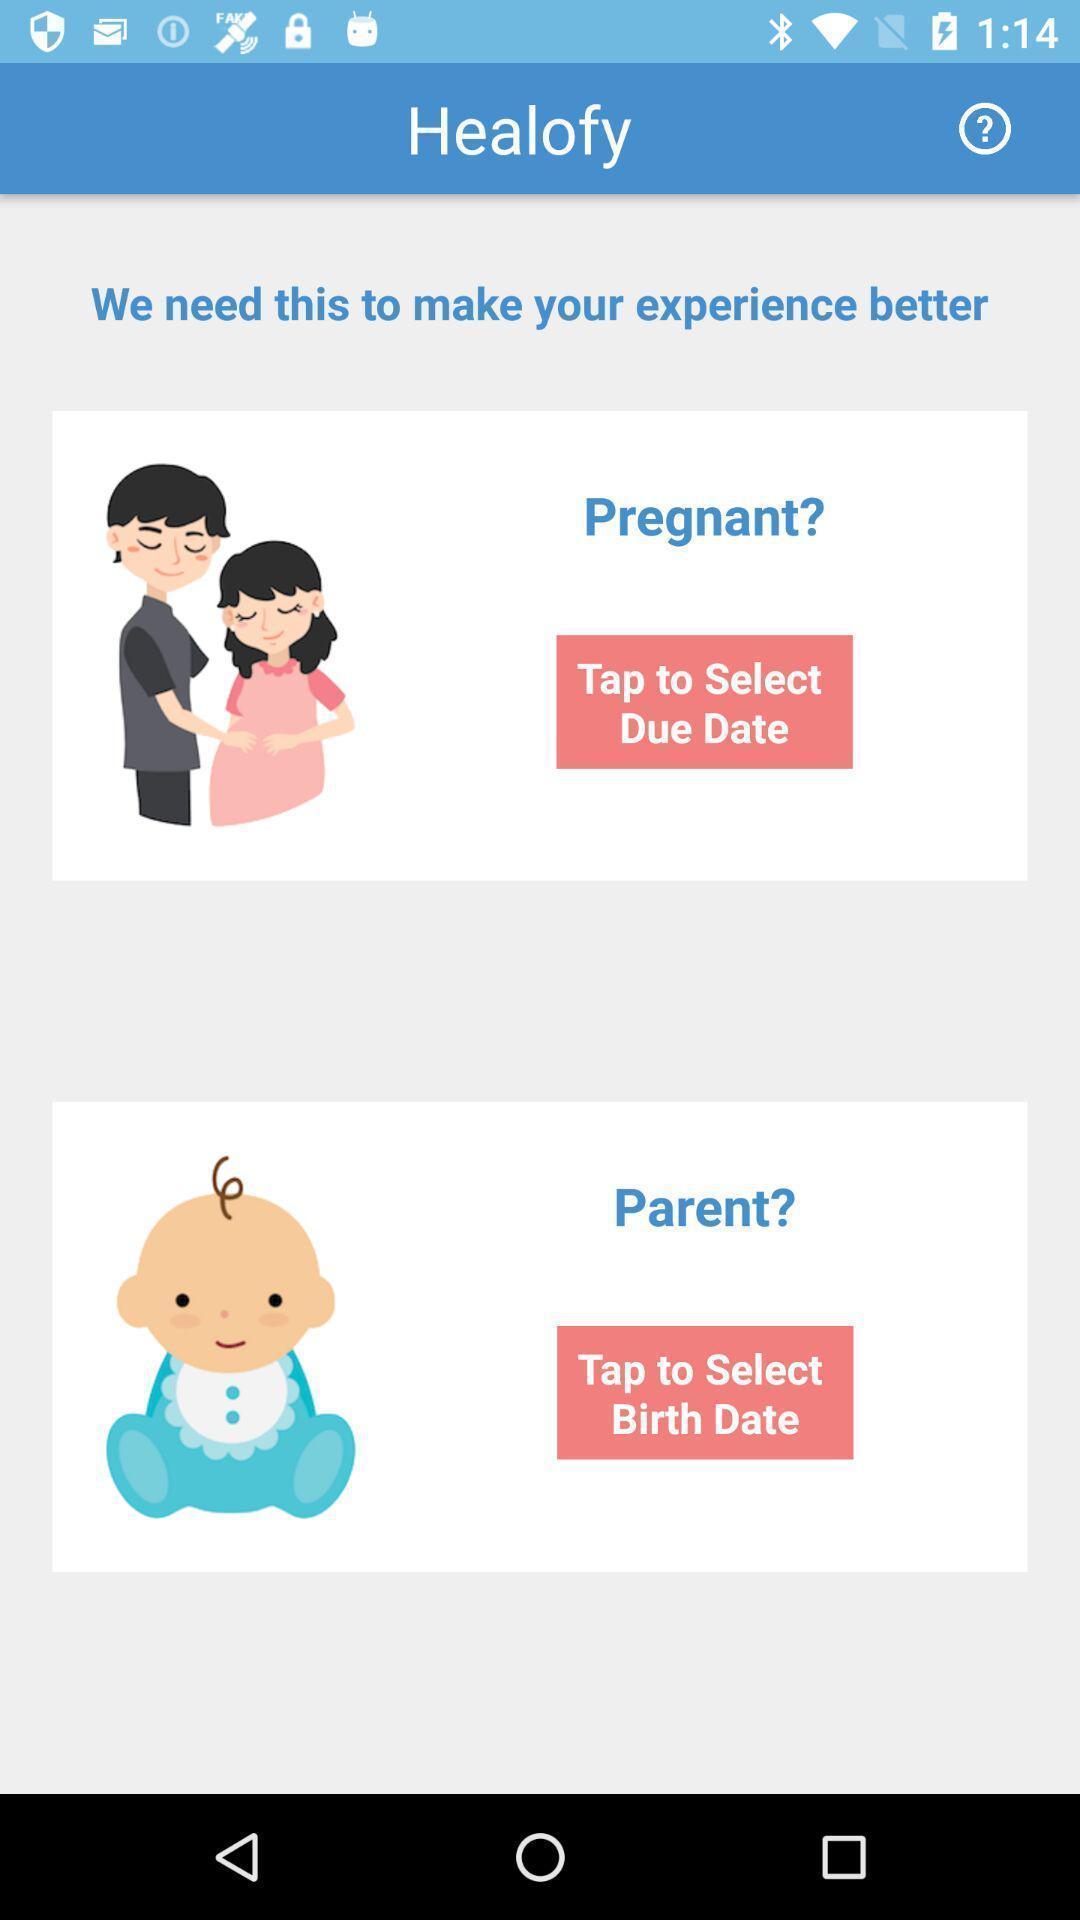Describe the key features of this screenshot. Screen page displaying options to select in health application. 